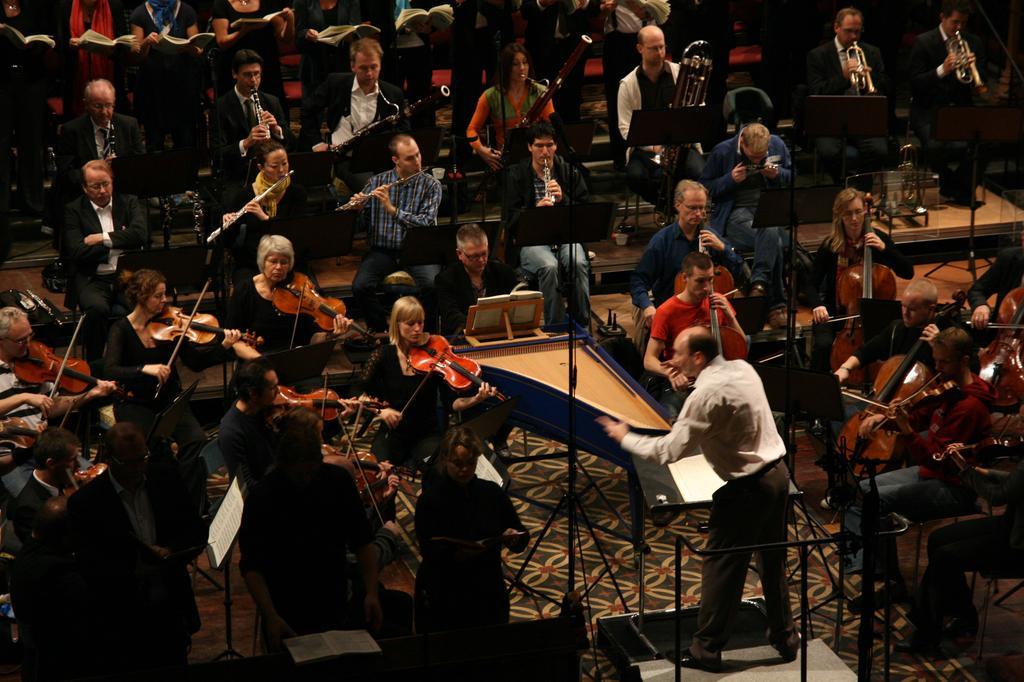Can you describe this image briefly? In this image we can see many people. Some are standing and some are sitting. Some people are holding books and some people are playing musical instruments. There are stands with books. 